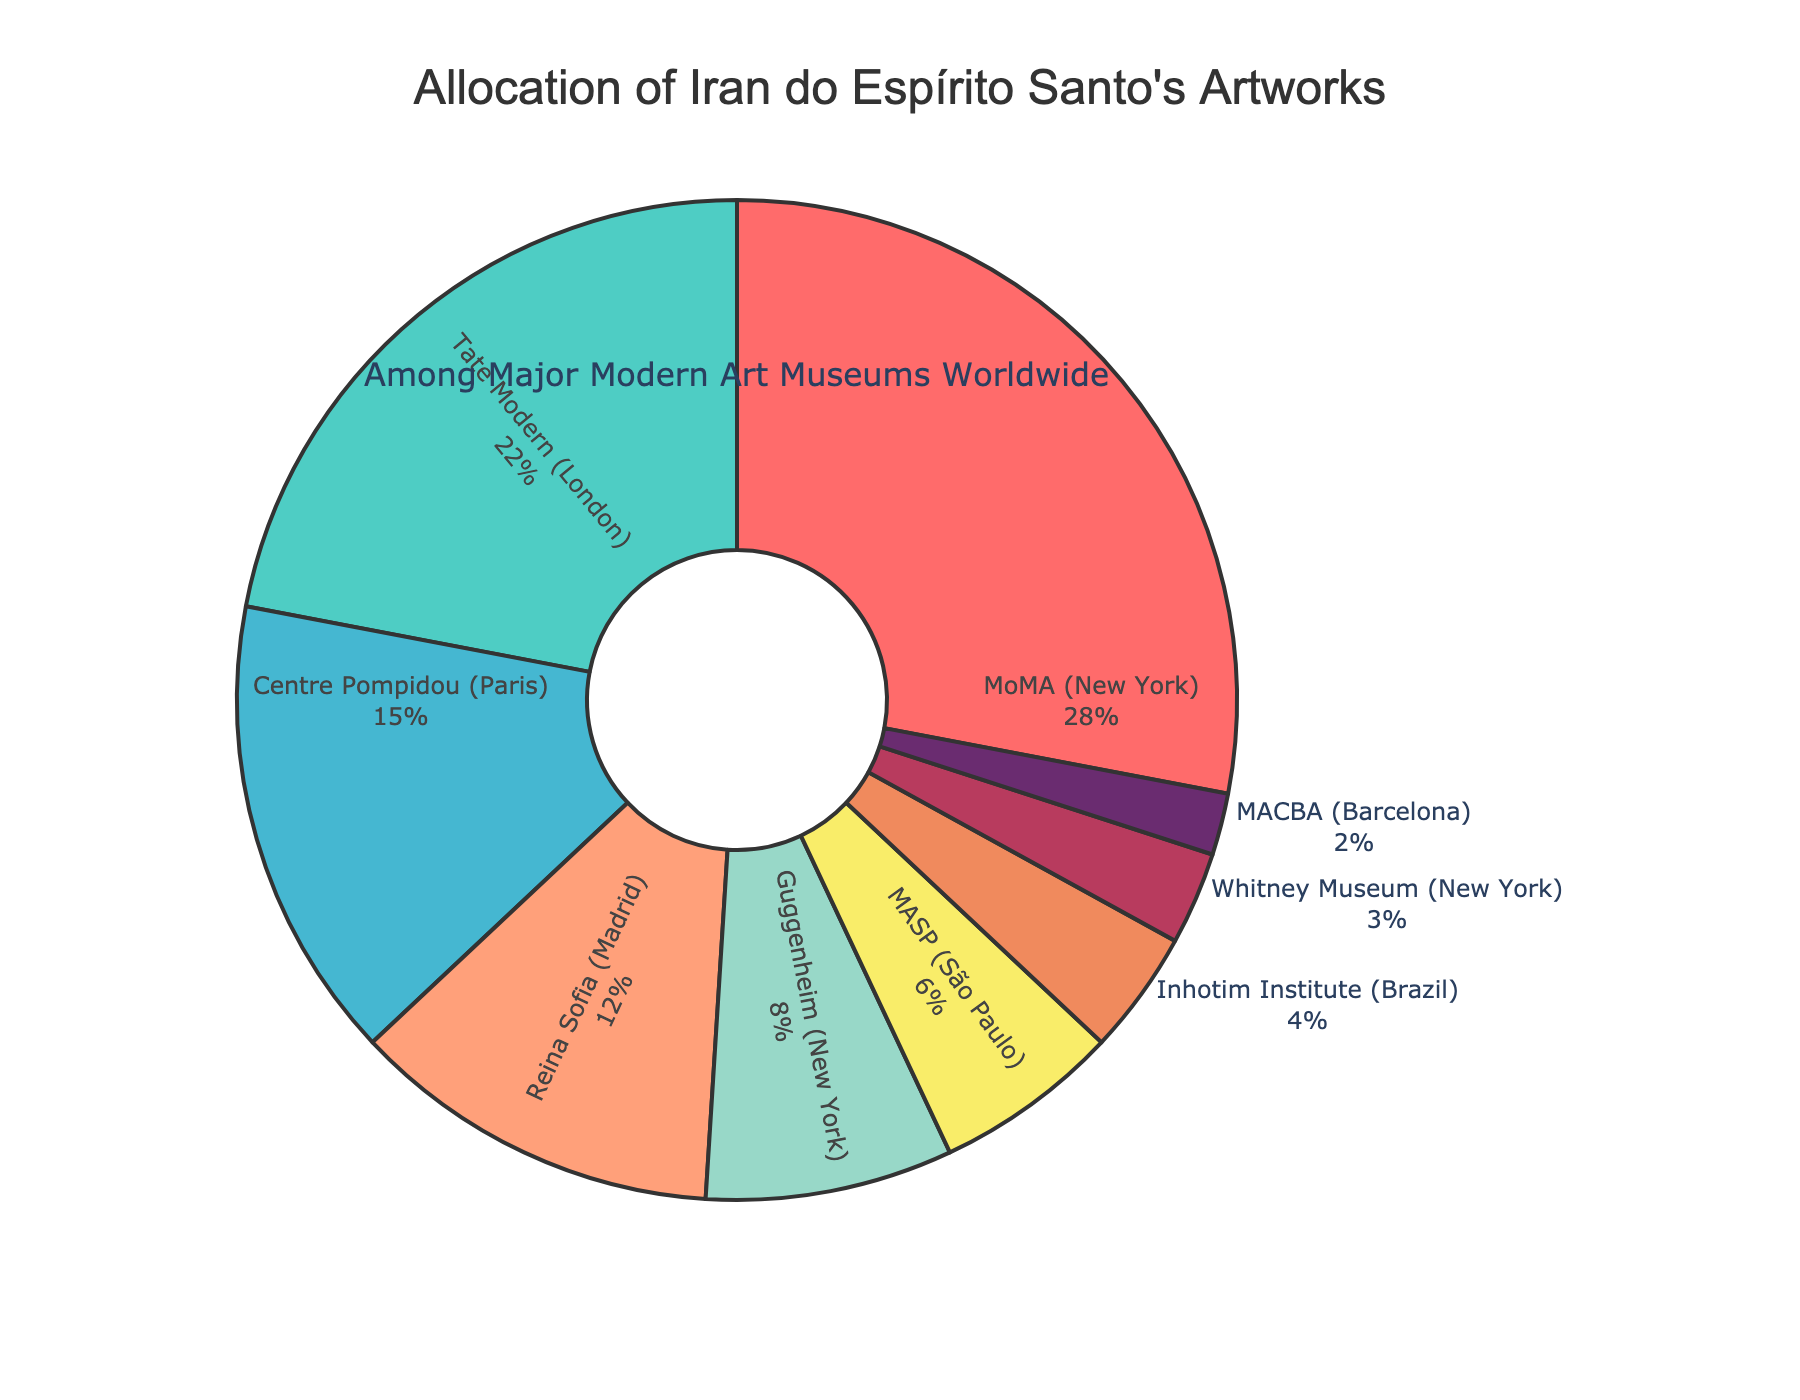What's the percentage allocation of Iran do Espírito Santo's artworks in MoMA compared to Tate Modern? To compare the percentage allocation, note that MoMA has 28% and Tate Modern has 22%. The difference is 28% - 22%, which equals 6%.
Answer: 6% Which museum holds the smallest percentage of Iran do Espírito Santo's artworks? By scanning the chart, the Whitney Museum (New York) holds the smallest percentage, which is 3%.
Answer: Whitney Museum What is the combined percentage of Iran do Espírito Santo's artworks in Centre Pompidou and Reina Sofia? Centre Pompidou has 15% and Reina Sofia has 12%. Adding these together, we get 15% + 12% = 27%.
Answer: 27% Does the Guggenheim (New York) hold more artworks than MASP (São Paulo)? The Guggenheim has 8%, while MASP has 6%. Since 8% is greater than 6%, the Guggenheim holds more artworks.
Answer: Yes How many museums have a higher percentage allocation than Inhotim Institute? The Inhotim Institute has 4%. MoMA (28%), Tate Modern (22%), Centre Pompidou (15%), Reina Sofia (12%), Guggenheim (8%), and MASP (6%) all have higher percentages. This totals to 6 museums.
Answer: 6 What is the total percentage of Iran do Espírito Santo's artworks held in New York museums? The New York museums listed are MoMA (28%), Guggenheim (8%), and Whitney Museum (3%). Adding these, we get 28% + 8% + 3% = 39%.
Answer: 39% Is the percentage of artworks in MASP and Inhotim Institute combined greater than that in the Whitney Museum? MASP has 6% and Inhotim Institute has 4%, so together they have 6% + 4% = 10%. The Whitney Museum has 3%. Since 10% is greater than 3%, the combined percentage is greater.
Answer: Yes What is the difference in percentage allocation between Centre Pompidou and Guggenheim? Centre Pompidou has 15% while Guggenheim has 8%. The difference is 15% - 8% = 7%.
Answer: 7% Which museum has the second highest percentage of Iran do Espírito Santo's artworks? The highest is MoMA with 28%. The second highest is Tate Modern with 22%.
Answer: Tate Modern What percentage do MoMA, Tate Modern, and Centre Pompidou combined account for? Adding their percentages together: MoMA (28%), Tate Modern (22%), and Centre Pompidou (15%), we get 28% + 22% + 15% = 65%.
Answer: 65% 